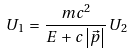Convert formula to latex. <formula><loc_0><loc_0><loc_500><loc_500>U _ { 1 } \, = \, \frac { m c ^ { 2 } } { E \, + \, c \left | \vec { p } \right | } \, U _ { 2 }</formula> 